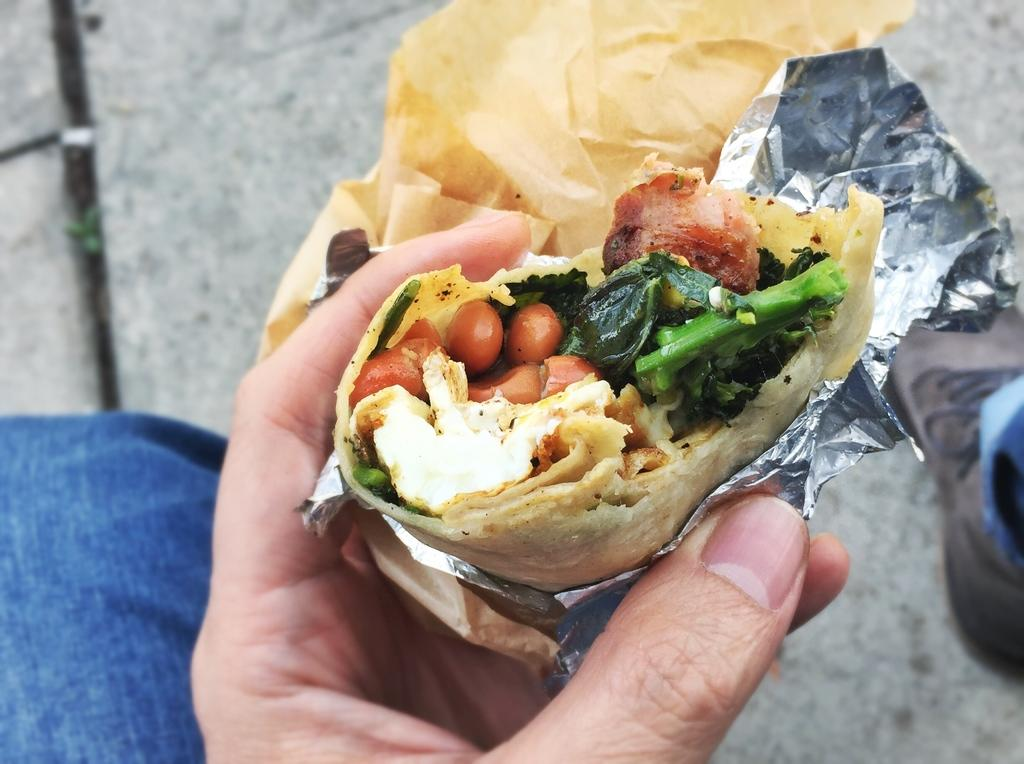What can be seen in the person's hand in the image? There is food in the person's hand in the image. What else is visible in the image besides the person's hand? There is a cover visible in the image. What type of scarf is wrapped around the giraffe in the image? There is no giraffe or scarf present in the image. How many potatoes can be seen in the person's hand in the image? There is no potato present in the person's hand in the image; it contains food. 